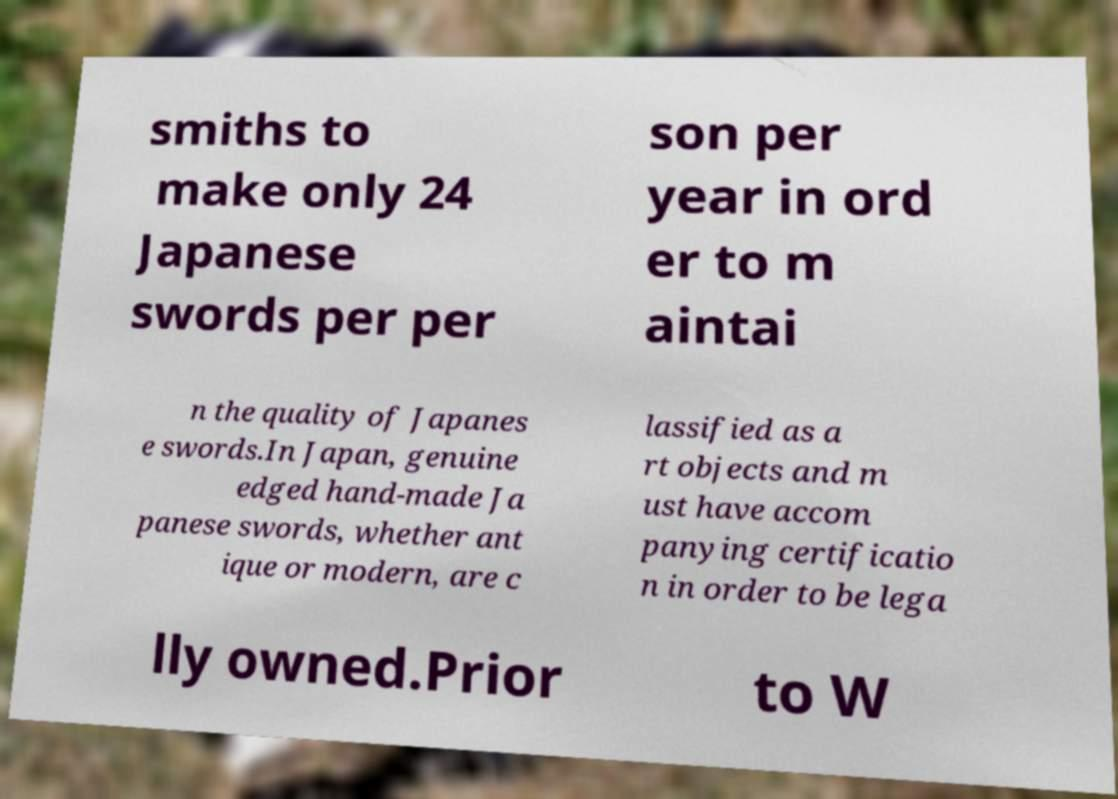Can you read and provide the text displayed in the image?This photo seems to have some interesting text. Can you extract and type it out for me? smiths to make only 24 Japanese swords per per son per year in ord er to m aintai n the quality of Japanes e swords.In Japan, genuine edged hand-made Ja panese swords, whether ant ique or modern, are c lassified as a rt objects and m ust have accom panying certificatio n in order to be lega lly owned.Prior to W 